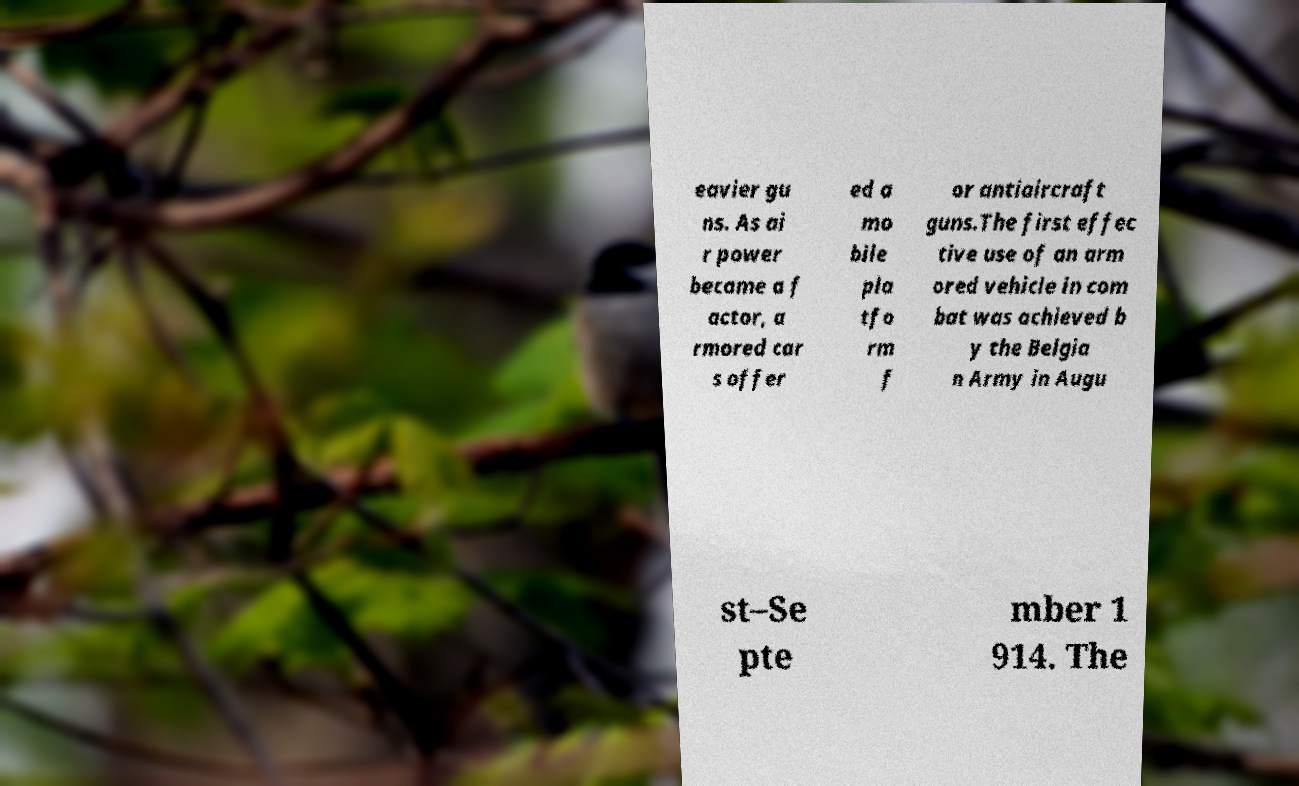What messages or text are displayed in this image? I need them in a readable, typed format. eavier gu ns. As ai r power became a f actor, a rmored car s offer ed a mo bile pla tfo rm f or antiaircraft guns.The first effec tive use of an arm ored vehicle in com bat was achieved b y the Belgia n Army in Augu st–Se pte mber 1 914. The 